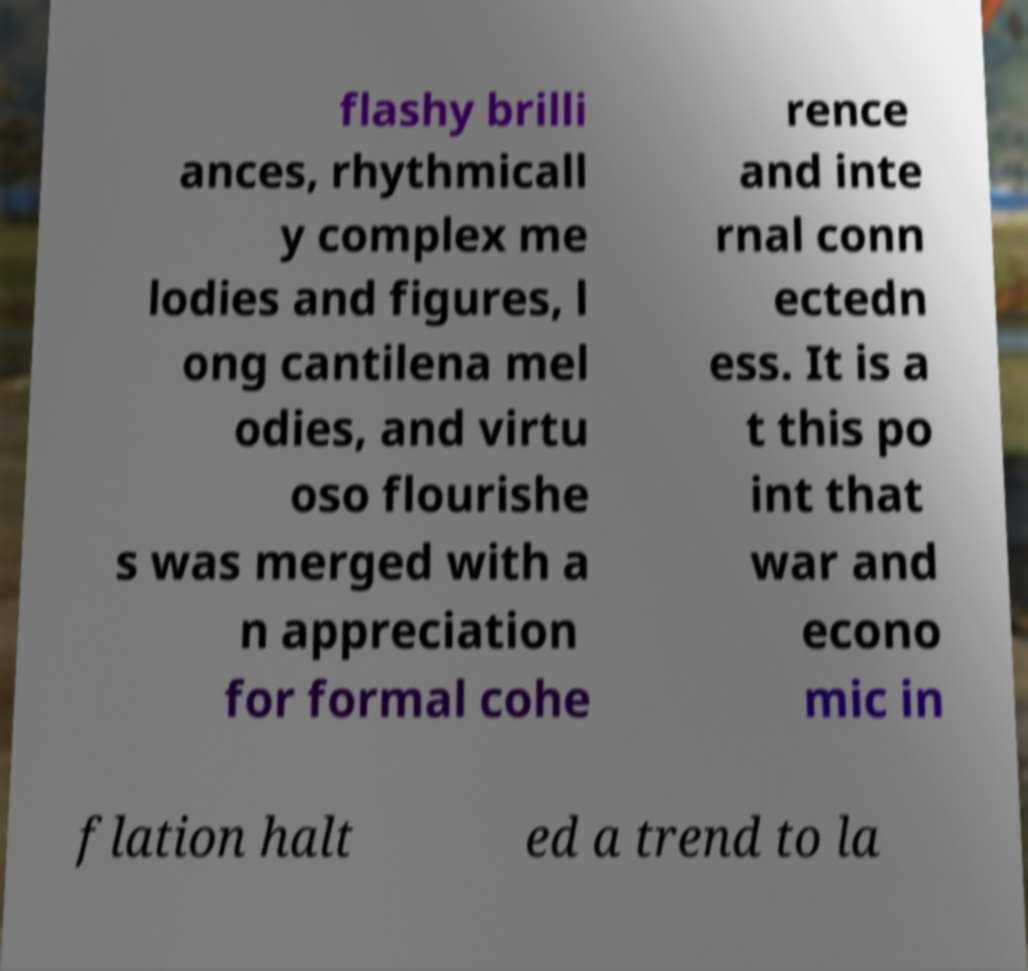There's text embedded in this image that I need extracted. Can you transcribe it verbatim? flashy brilli ances, rhythmicall y complex me lodies and figures, l ong cantilena mel odies, and virtu oso flourishe s was merged with a n appreciation for formal cohe rence and inte rnal conn ectedn ess. It is a t this po int that war and econo mic in flation halt ed a trend to la 